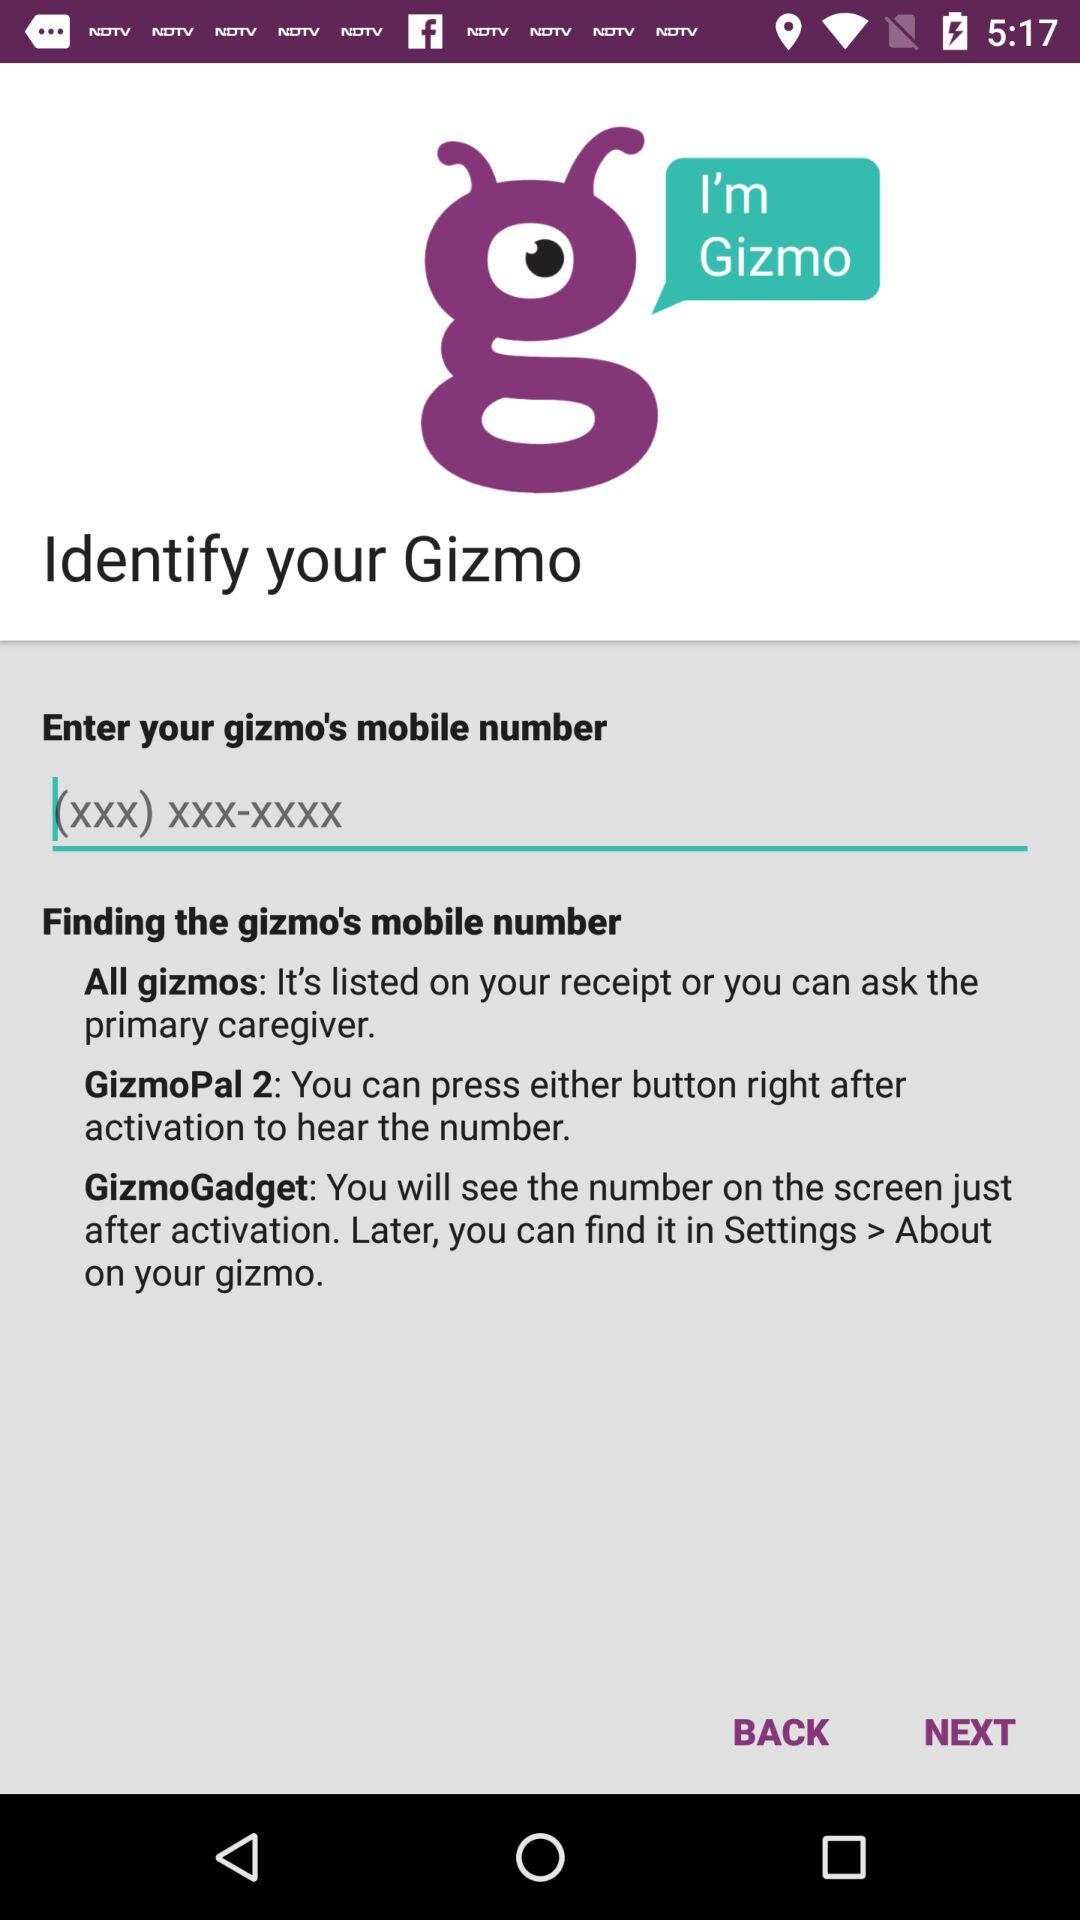What is the name of the application? The name of the application is "I'm Gizmo". 